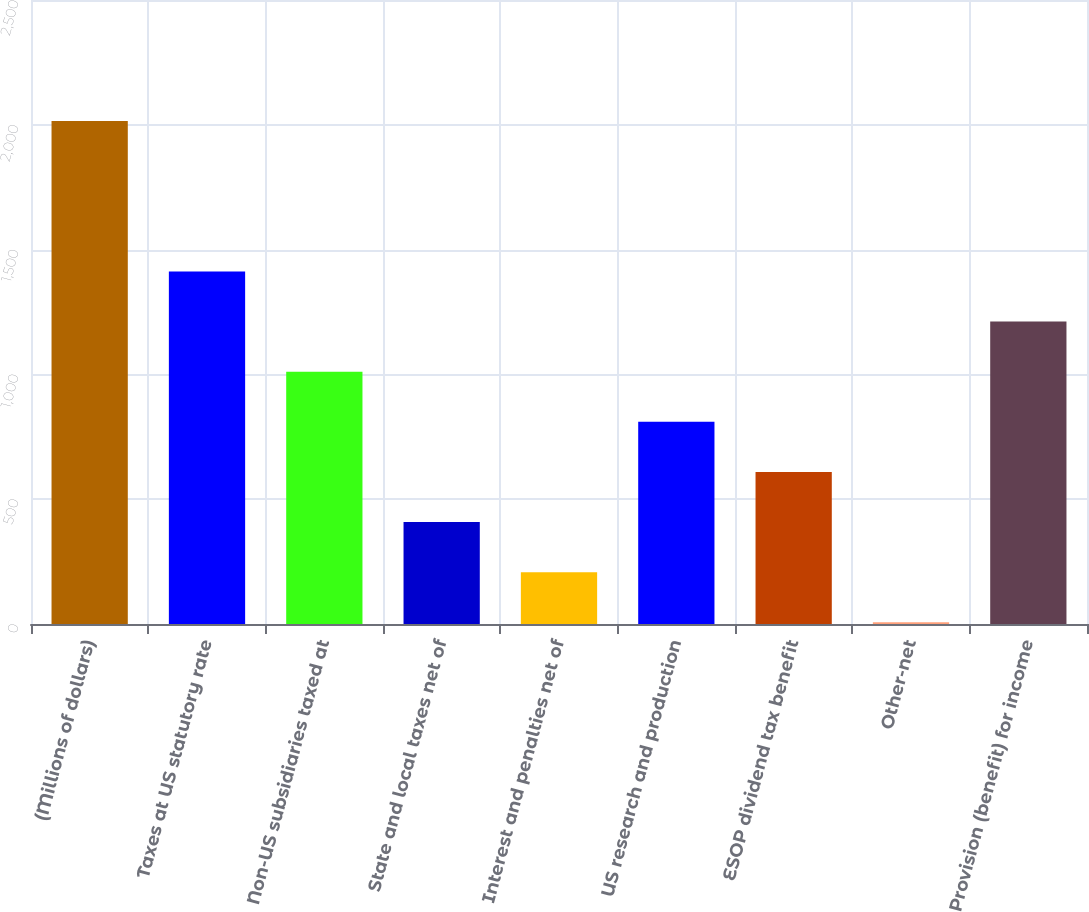Convert chart. <chart><loc_0><loc_0><loc_500><loc_500><bar_chart><fcel>(Millions of dollars)<fcel>Taxes at US statutory rate<fcel>Non-US subsidiaries taxed at<fcel>State and local taxes net of<fcel>Interest and penalties net of<fcel>US research and production<fcel>ESOP dividend tax benefit<fcel>Other-net<fcel>Provision (benefit) for income<nl><fcel>2015<fcel>1412.6<fcel>1011<fcel>408.6<fcel>207.8<fcel>810.2<fcel>609.4<fcel>7<fcel>1211.8<nl></chart> 